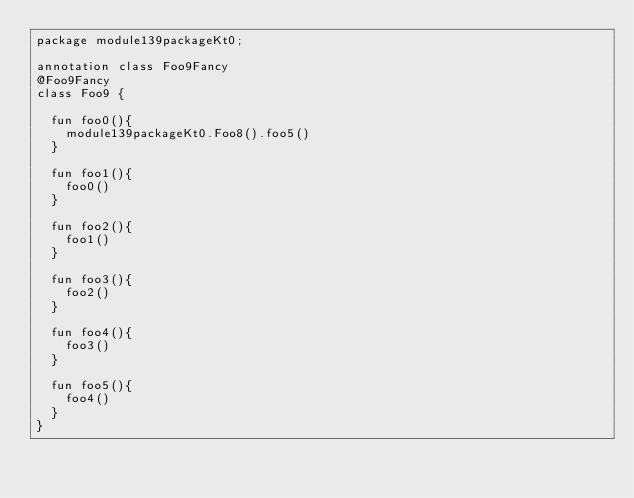<code> <loc_0><loc_0><loc_500><loc_500><_Kotlin_>package module139packageKt0;

annotation class Foo9Fancy
@Foo9Fancy
class Foo9 {

  fun foo0(){
    module139packageKt0.Foo8().foo5()
  }

  fun foo1(){
    foo0()
  }

  fun foo2(){
    foo1()
  }

  fun foo3(){
    foo2()
  }

  fun foo4(){
    foo3()
  }

  fun foo5(){
    foo4()
  }
}</code> 